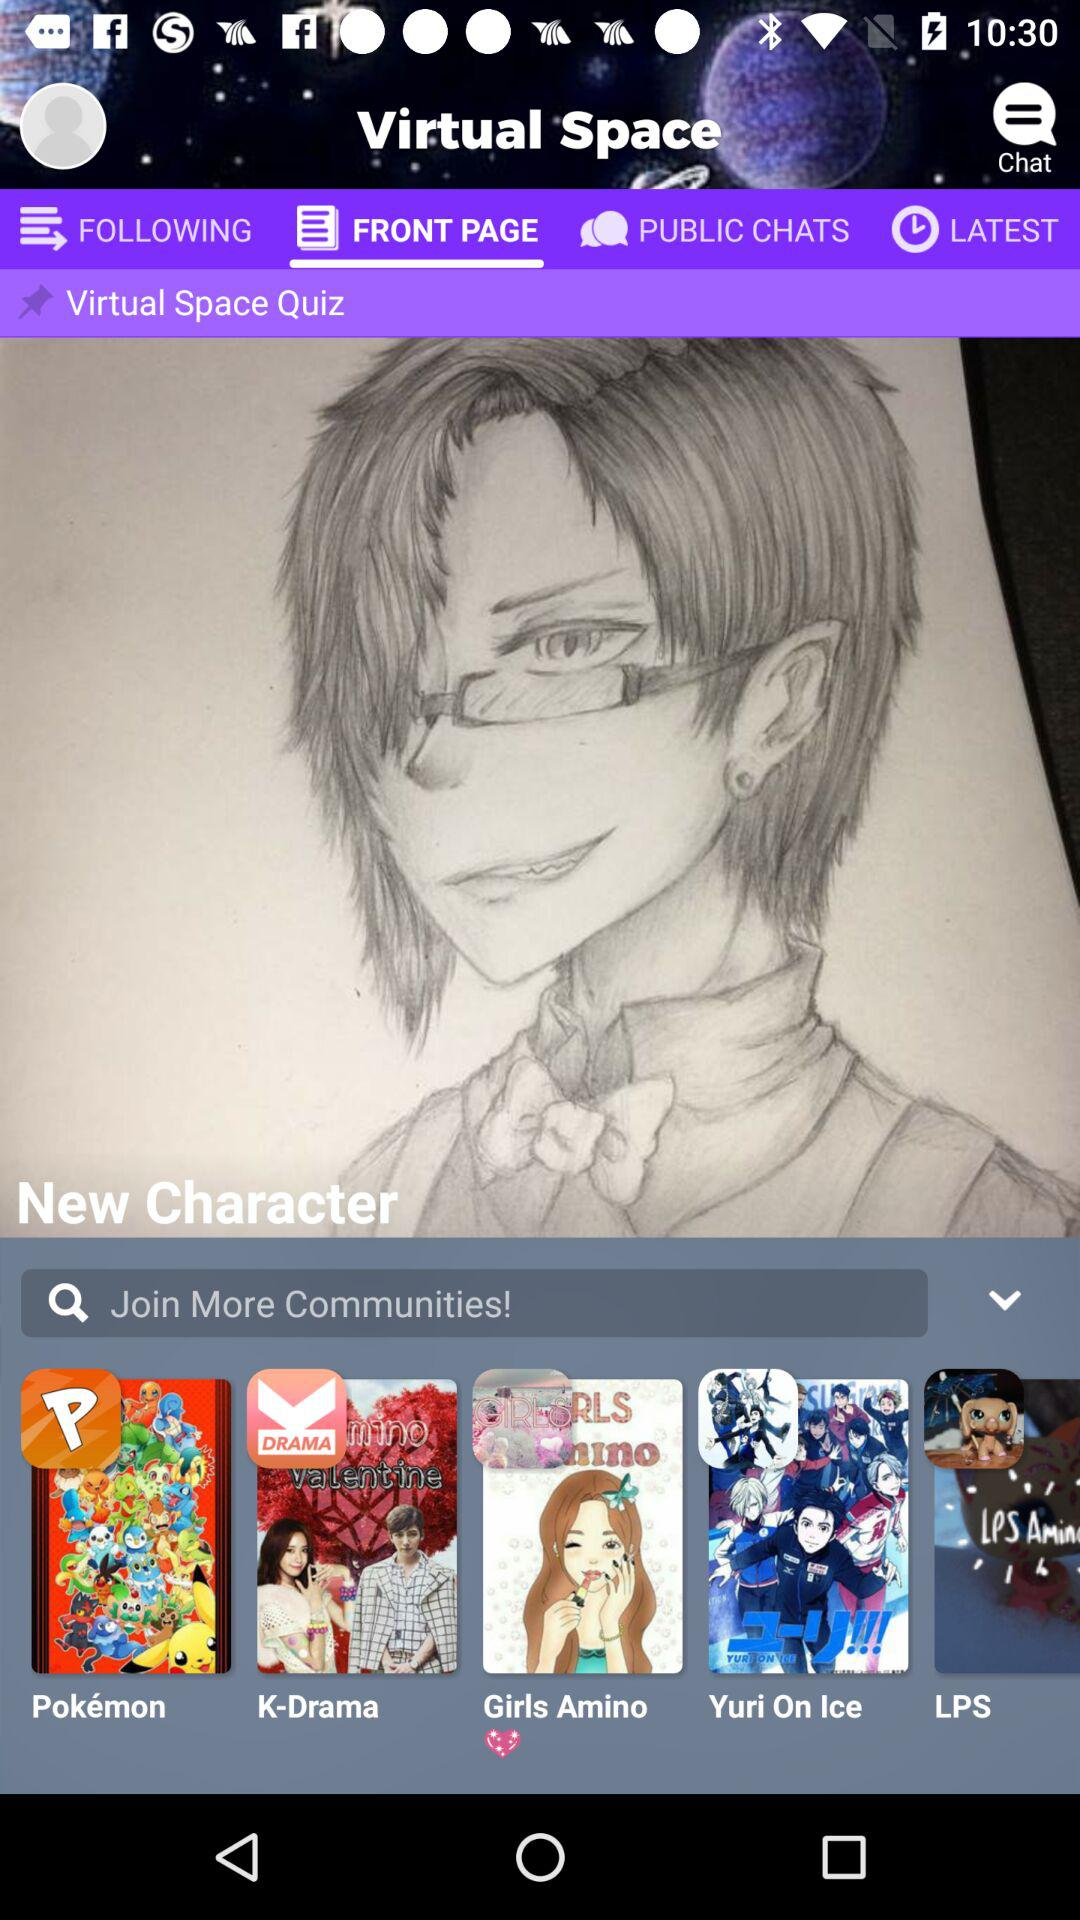What is the app name? The app name is "Virtual Space". 